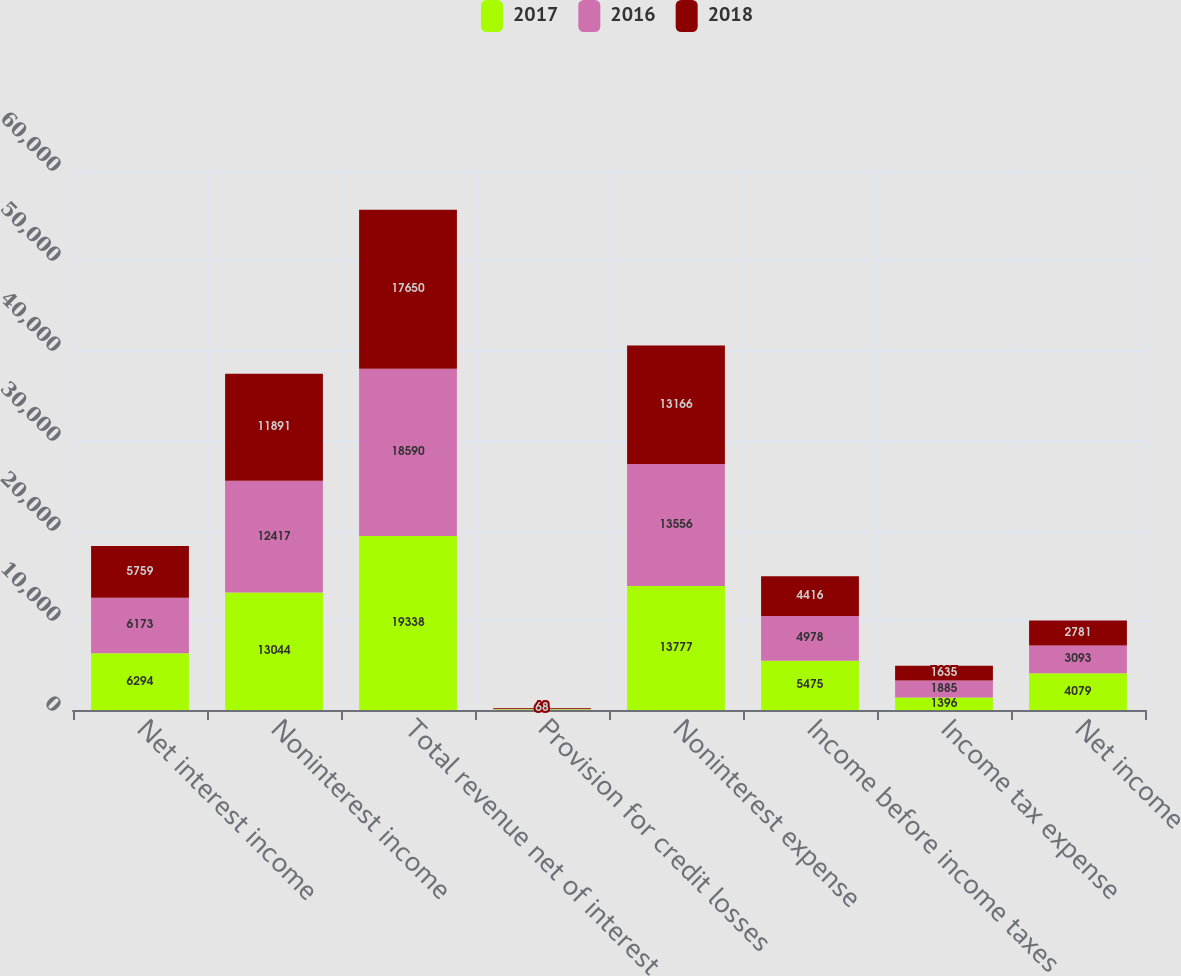Convert chart. <chart><loc_0><loc_0><loc_500><loc_500><stacked_bar_chart><ecel><fcel>Net interest income<fcel>Noninterest income<fcel>Total revenue net of interest<fcel>Provision for credit losses<fcel>Noninterest expense<fcel>Income before income taxes<fcel>Income tax expense<fcel>Net income<nl><fcel>2017<fcel>6294<fcel>13044<fcel>19338<fcel>86<fcel>13777<fcel>5475<fcel>1396<fcel>4079<nl><fcel>2016<fcel>6173<fcel>12417<fcel>18590<fcel>56<fcel>13556<fcel>4978<fcel>1885<fcel>3093<nl><fcel>2018<fcel>5759<fcel>11891<fcel>17650<fcel>68<fcel>13166<fcel>4416<fcel>1635<fcel>2781<nl></chart> 